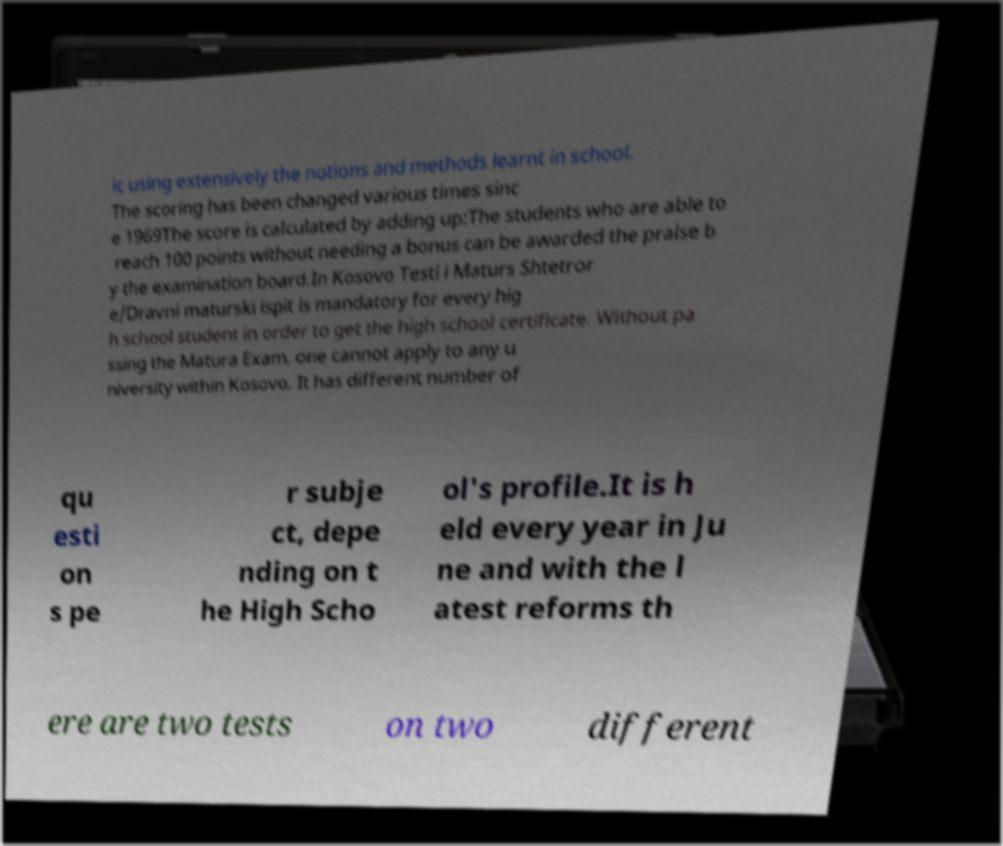Can you read and provide the text displayed in the image?This photo seems to have some interesting text. Can you extract and type it out for me? ic using extensively the notions and methods learnt in school. The scoring has been changed various times sinc e 1969The score is calculated by adding up:The students who are able to reach 100 points without needing a bonus can be awarded the praise b y the examination board.In Kosovo Testi i Maturs Shtetror e/Dravni maturski ispit is mandatory for every hig h school student in order to get the high school certificate. Without pa ssing the Matura Exam, one cannot apply to any u niversity within Kosovo. It has different number of qu esti on s pe r subje ct, depe nding on t he High Scho ol's profile.It is h eld every year in Ju ne and with the l atest reforms th ere are two tests on two different 